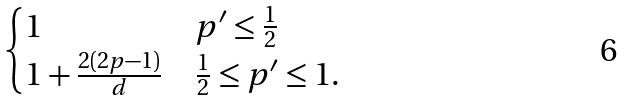<formula> <loc_0><loc_0><loc_500><loc_500>\begin{cases} 1 & p ^ { \prime } \leq \frac { 1 } { 2 } \\ 1 + \frac { 2 ( 2 p - 1 ) } { d } & \frac { 1 } { 2 } \leq p ^ { \prime } \leq 1 . \end{cases}</formula> 